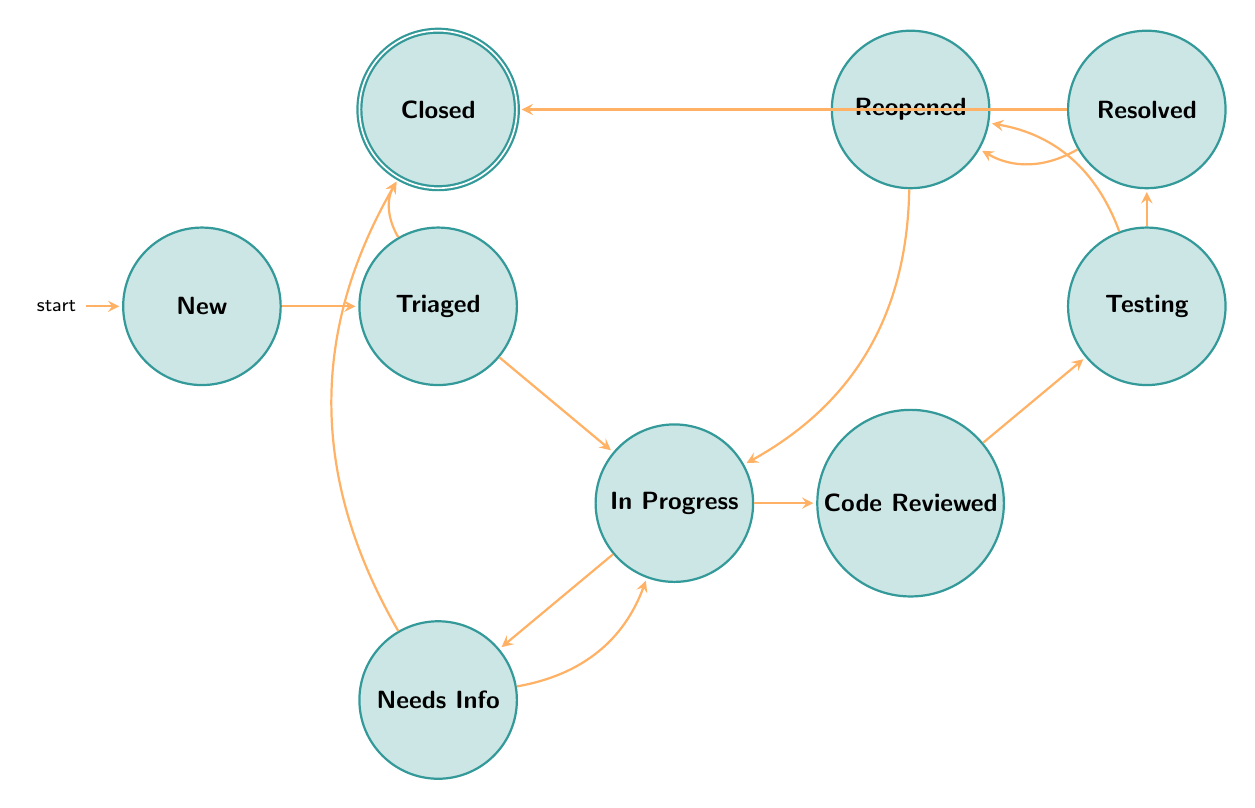What is the initial state of the workflow? The initial state is represented by the node labeled "New" in the diagram, which indicates that the bug is newly reported and unprocessed.
Answer: New How many total states are there in the diagram? By counting each of the distinct nodes in the diagram, there are nine states: New, Triaged, In Progress, Needs Info, Code Reviewed, Testing, Resolved, Reopened, and Closed.
Answer: Nine What transition occurs after a bug is "Triaged"? From the "Triaged" state, a bug can transition to either "In Progress" or "Closed" based on the priorities set after acknowledging the bug.
Answer: In Progress, Closed What happens if additional information is required after a bug is "In Progress"? If additional information is required, the bug will transition to the "Needs Info" state, where it remains until more information is provided or the bug is closed.
Answer: Needs Info How many transitions are possible from the "Testing" state? The "Testing" state has two possible transitions, leading either to "Resolved" if the bug is fixed or to "Reopened" if the bug persists.
Answer: Two Which state has no outgoing transitions? The "Closed" state has no outgoing transitions, meaning that once a bug is closed, no further action is taken on it.
Answer: Closed What is the next state after a bug is "Resolved"? After a bug is "Resolved," it can transition to either "Closed," indicating that the bug has been finalized, or "Reopened," if the bug is found again.
Answer: Closed, Reopened If a bug is found again after being "Resolved," which state does it move to? If a bug is found again after being resolved, it transitions to the "Reopened" state, which signifies a re-evaluation of the bug.
Answer: Reopened What are the two possible outcomes after the "Needs Info" state? After being in the "Needs Info" state, the bug can either go back to "In Progress" once the necessary information is received or transition directly to "Closed."
Answer: In Progress, Closed 